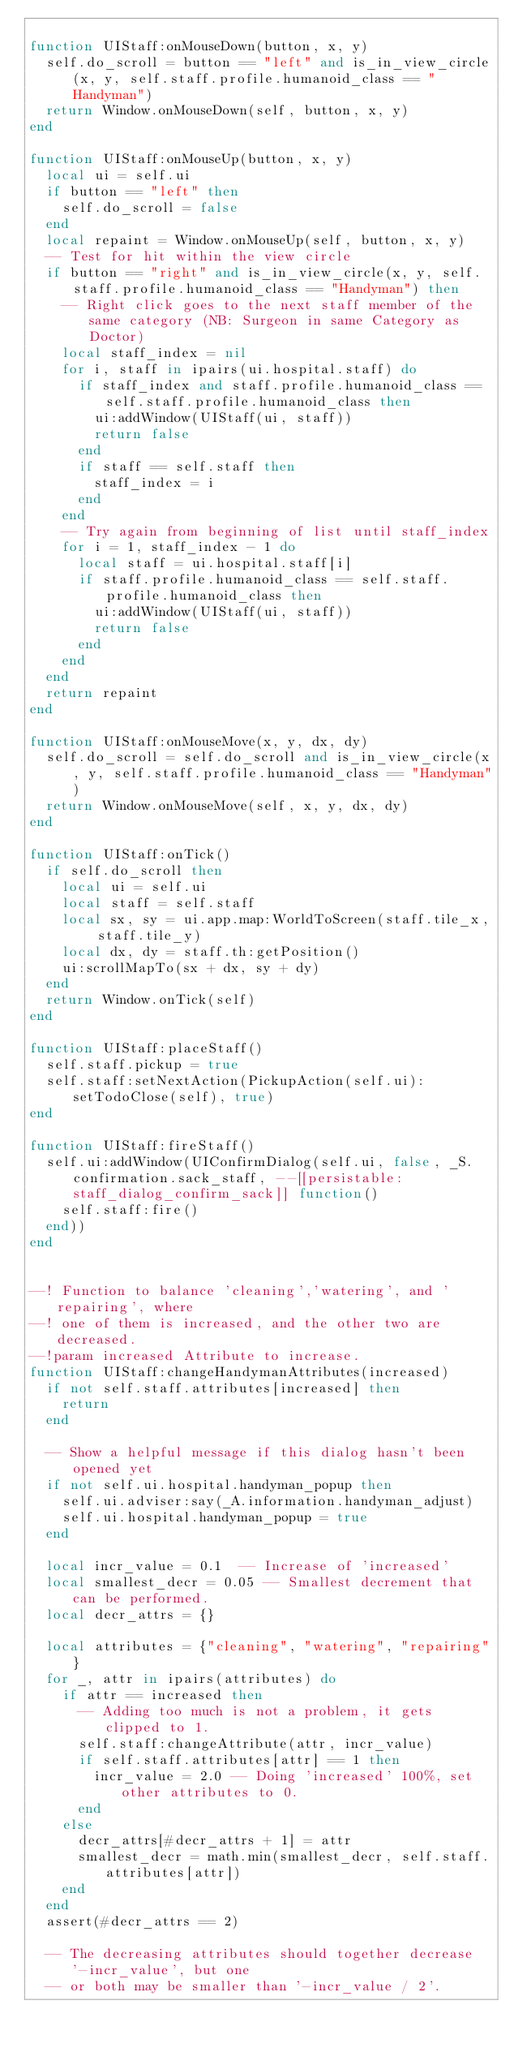<code> <loc_0><loc_0><loc_500><loc_500><_Lua_>
function UIStaff:onMouseDown(button, x, y)
  self.do_scroll = button == "left" and is_in_view_circle(x, y, self.staff.profile.humanoid_class == "Handyman")
  return Window.onMouseDown(self, button, x, y)
end

function UIStaff:onMouseUp(button, x, y)
  local ui = self.ui
  if button == "left" then
    self.do_scroll = false
  end
  local repaint = Window.onMouseUp(self, button, x, y)
  -- Test for hit within the view circle
  if button == "right" and is_in_view_circle(x, y, self.staff.profile.humanoid_class == "Handyman") then
    -- Right click goes to the next staff member of the same category (NB: Surgeon in same Category as Doctor)
    local staff_index = nil
    for i, staff in ipairs(ui.hospital.staff) do
      if staff_index and staff.profile.humanoid_class == self.staff.profile.humanoid_class then
        ui:addWindow(UIStaff(ui, staff))
        return false
      end
      if staff == self.staff then
        staff_index = i
      end
    end
    -- Try again from beginning of list until staff_index
    for i = 1, staff_index - 1 do
      local staff = ui.hospital.staff[i]
      if staff.profile.humanoid_class == self.staff.profile.humanoid_class then
        ui:addWindow(UIStaff(ui, staff))
        return false
      end
    end
  end
  return repaint
end

function UIStaff:onMouseMove(x, y, dx, dy)
  self.do_scroll = self.do_scroll and is_in_view_circle(x, y, self.staff.profile.humanoid_class == "Handyman")
  return Window.onMouseMove(self, x, y, dx, dy)
end

function UIStaff:onTick()
  if self.do_scroll then
    local ui = self.ui
    local staff = self.staff
    local sx, sy = ui.app.map:WorldToScreen(staff.tile_x, staff.tile_y)
    local dx, dy = staff.th:getPosition()
    ui:scrollMapTo(sx + dx, sy + dy)
  end
  return Window.onTick(self)
end

function UIStaff:placeStaff()
  self.staff.pickup = true
  self.staff:setNextAction(PickupAction(self.ui):setTodoClose(self), true)
end

function UIStaff:fireStaff()
  self.ui:addWindow(UIConfirmDialog(self.ui, false, _S.confirmation.sack_staff, --[[persistable:staff_dialog_confirm_sack]] function()
    self.staff:fire()
  end))
end


--! Function to balance 'cleaning','watering', and 'repairing', where
--! one of them is increased, and the other two are decreased.
--!param increased Attribute to increase.
function UIStaff:changeHandymanAttributes(increased)
  if not self.staff.attributes[increased] then
    return
  end

  -- Show a helpful message if this dialog hasn't been opened yet
  if not self.ui.hospital.handyman_popup then
    self.ui.adviser:say(_A.information.handyman_adjust)
    self.ui.hospital.handyman_popup = true
  end

  local incr_value = 0.1  -- Increase of 'increased'
  local smallest_decr = 0.05 -- Smallest decrement that can be performed.
  local decr_attrs = {}

  local attributes = {"cleaning", "watering", "repairing"}
  for _, attr in ipairs(attributes) do
    if attr == increased then
      -- Adding too much is not a problem, it gets clipped to 1.
      self.staff:changeAttribute(attr, incr_value)
      if self.staff.attributes[attr] == 1 then
        incr_value = 2.0 -- Doing 'increased' 100%, set other attributes to 0.
      end
    else
      decr_attrs[#decr_attrs + 1] = attr
      smallest_decr = math.min(smallest_decr, self.staff.attributes[attr])
    end
  end
  assert(#decr_attrs == 2)

  -- The decreasing attributes should together decrease '-incr_value', but one
  -- or both may be smaller than '-incr_value / 2'.</code> 